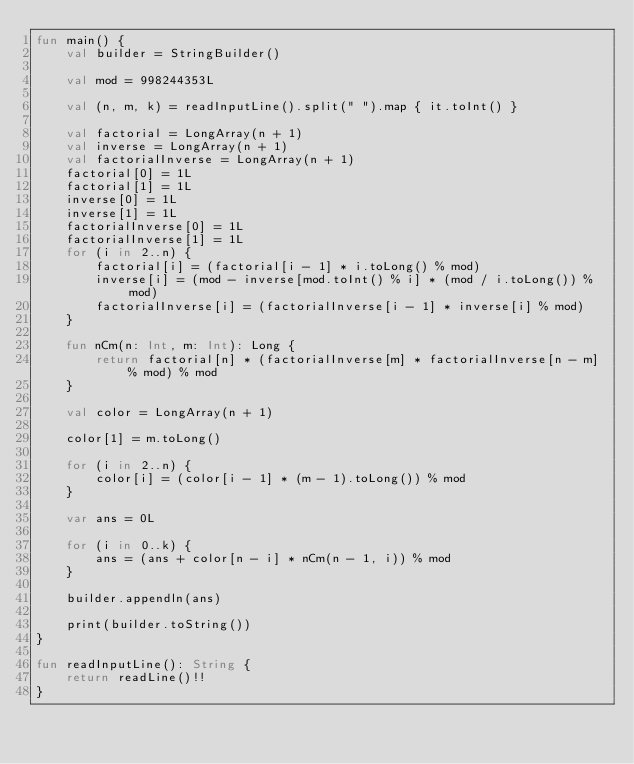<code> <loc_0><loc_0><loc_500><loc_500><_Kotlin_>fun main() {
    val builder = StringBuilder()

    val mod = 998244353L

    val (n, m, k) = readInputLine().split(" ").map { it.toInt() }

    val factorial = LongArray(n + 1)
    val inverse = LongArray(n + 1)
    val factorialInverse = LongArray(n + 1)
    factorial[0] = 1L
    factorial[1] = 1L
    inverse[0] = 1L
    inverse[1] = 1L
    factorialInverse[0] = 1L
    factorialInverse[1] = 1L
    for (i in 2..n) {
        factorial[i] = (factorial[i - 1] * i.toLong() % mod)
        inverse[i] = (mod - inverse[mod.toInt() % i] * (mod / i.toLong()) % mod)
        factorialInverse[i] = (factorialInverse[i - 1] * inverse[i] % mod)
    }

    fun nCm(n: Int, m: Int): Long {
        return factorial[n] * (factorialInverse[m] * factorialInverse[n - m] % mod) % mod
    }

    val color = LongArray(n + 1)

    color[1] = m.toLong()

    for (i in 2..n) {
        color[i] = (color[i - 1] * (m - 1).toLong()) % mod
    }

    var ans = 0L

    for (i in 0..k) {
        ans = (ans + color[n - i] * nCm(n - 1, i)) % mod
    }

    builder.appendln(ans)

    print(builder.toString())
}

fun readInputLine(): String {
    return readLine()!!
}
</code> 